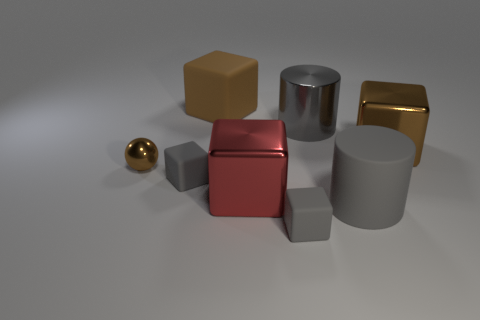What could these objects represent in a symbolic manner? The arrangement of these objects could symbolize diversity and uniqueness, as each shape and color stands out yet complements the others, possibly reflecting on how various elements can come together harmoniously. How might you interpret the golden sphere? The golden sphere might represent perfection or wholeness due to its seamless shape and lustrous finish. Its small size and placement could indicate the value of even the smallest contributions within a larger group. 